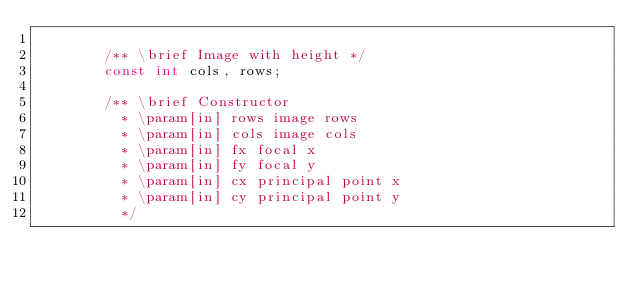<code> <loc_0><loc_0><loc_500><loc_500><_C_>
        /** \brief Image with height */ 
        const int cols, rows;      
        
        /** \brief Constructor 
          * \param[in] rows image rows
          * \param[in] cols image cols
          * \param[in] fx focal x
          * \param[in] fy focal y
          * \param[in] cx principal point x
          * \param[in] cy principal point y
          */</code> 